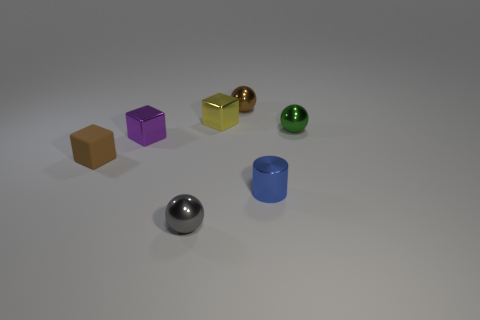Do these objects have a common theme or category? Yes, all the objects appear to be simplistic geometric shapes which could be used to teach or demonstrate geometry and spatial concepts. Could these objects be part of a game or educational tool? Absolutely, they could be part of an educational set for teaching shapes, colors, and materials or used in a matching or sorting game for children. 